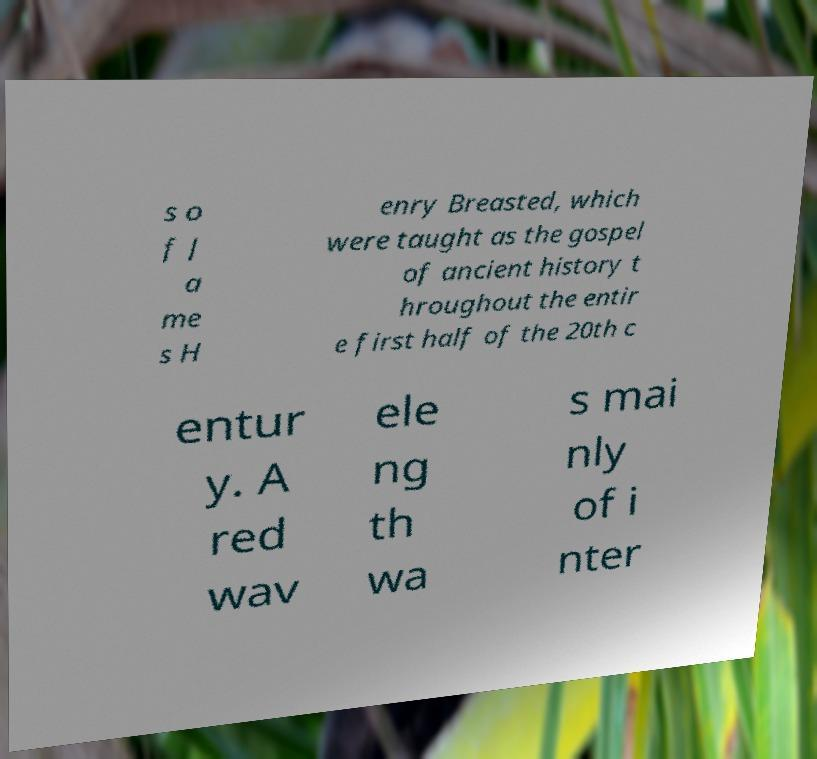Can you accurately transcribe the text from the provided image for me? s o f J a me s H enry Breasted, which were taught as the gospel of ancient history t hroughout the entir e first half of the 20th c entur y. A red wav ele ng th wa s mai nly of i nter 